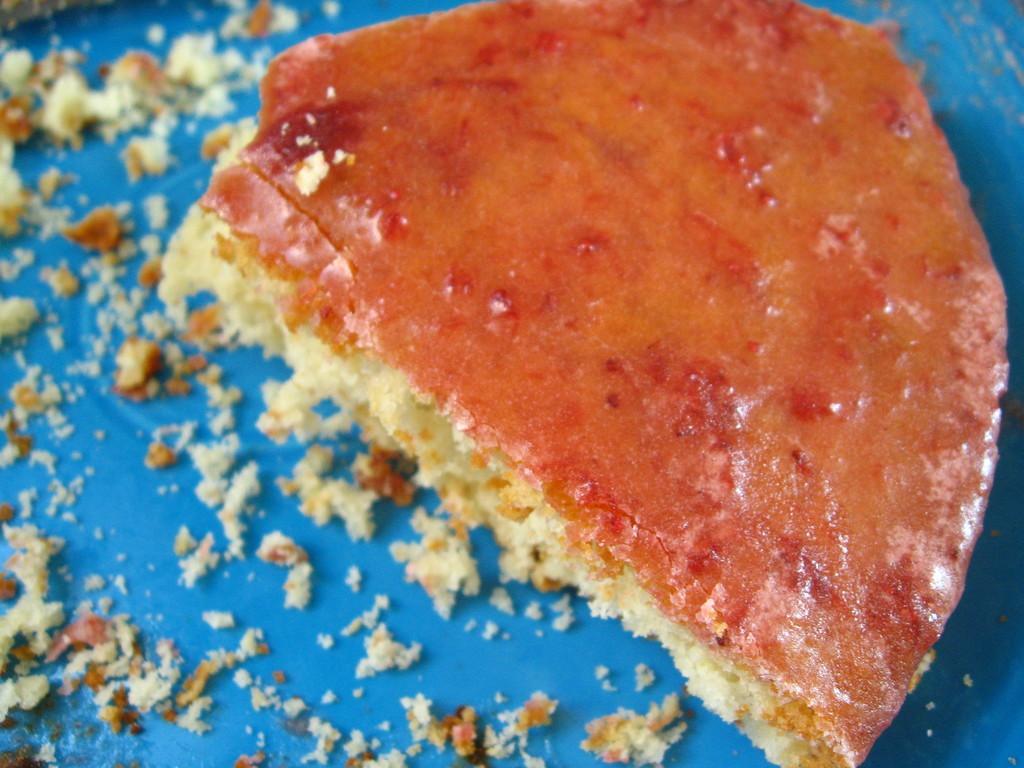Describe this image in one or two sentences. In this picture i can see food item on a blue color object. 